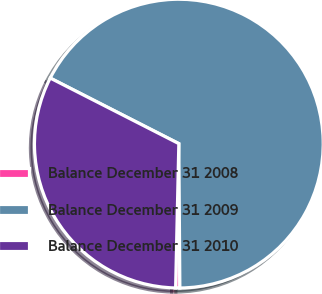Convert chart to OTSL. <chart><loc_0><loc_0><loc_500><loc_500><pie_chart><fcel>Balance December 31 2008<fcel>Balance December 31 2009<fcel>Balance December 31 2010<nl><fcel>0.47%<fcel>67.38%<fcel>32.15%<nl></chart> 